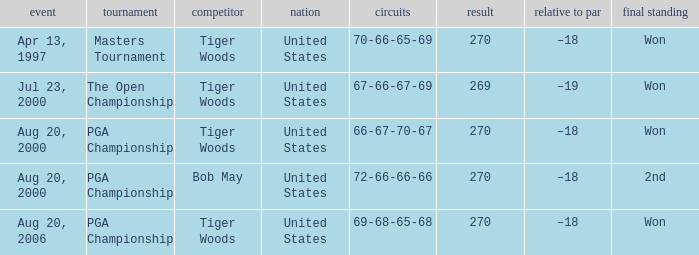What days were the rounds of 66-67-70-67 recorded? Aug 20, 2000. 